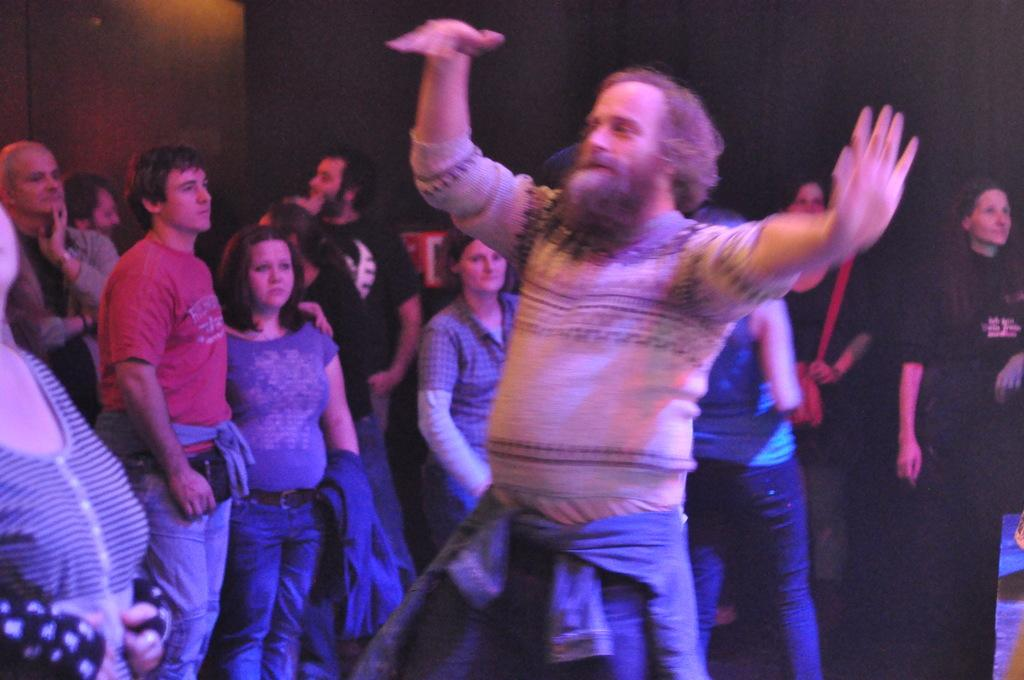What is the main subject of the image? There is a man in the middle of the image dancing. What can be seen in the background of the image? There is a group of people in the background of the image. What are the people in the background doing? The group of people are standing and looking to the right side. Can you see any wounds on the man's chin in the image? There is no mention of any wounds or the man's chin in the provided facts, so we cannot determine if there are any wounds present. 